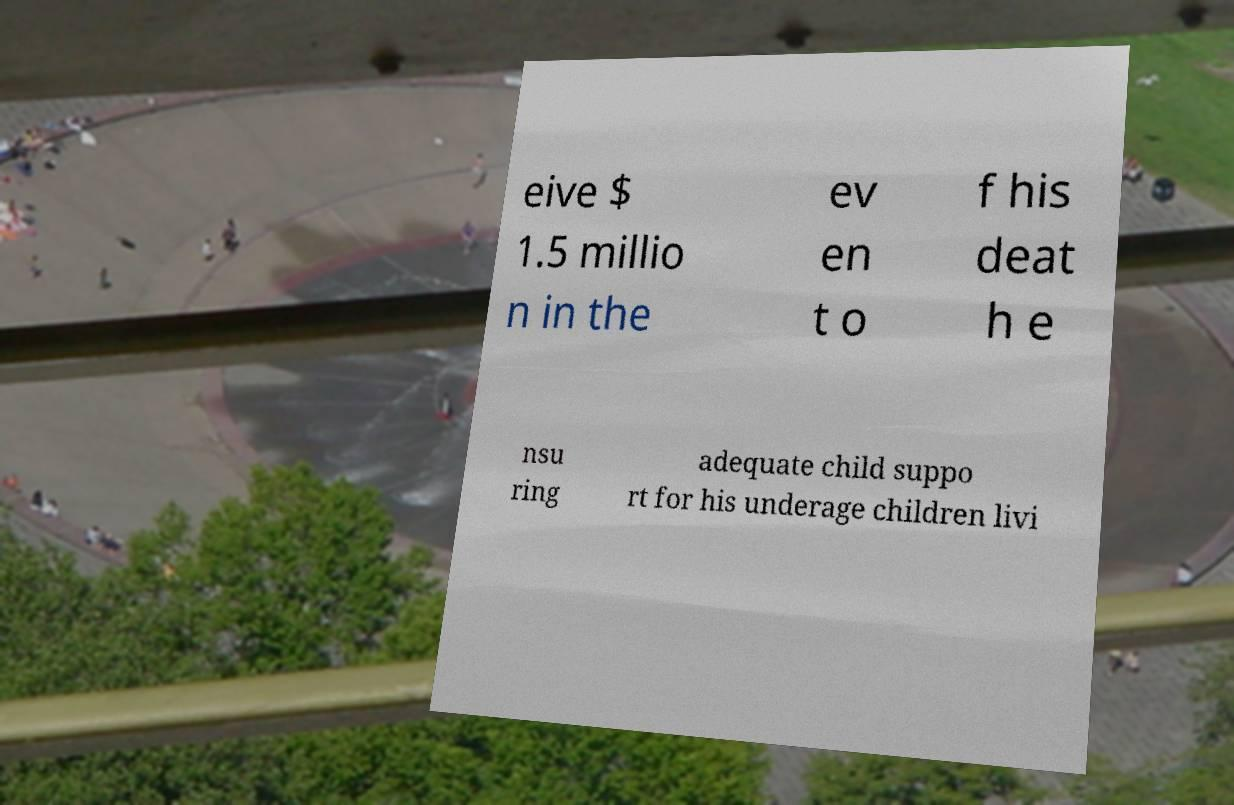Could you assist in decoding the text presented in this image and type it out clearly? eive $ 1.5 millio n in the ev en t o f his deat h e nsu ring adequate child suppo rt for his underage children livi 